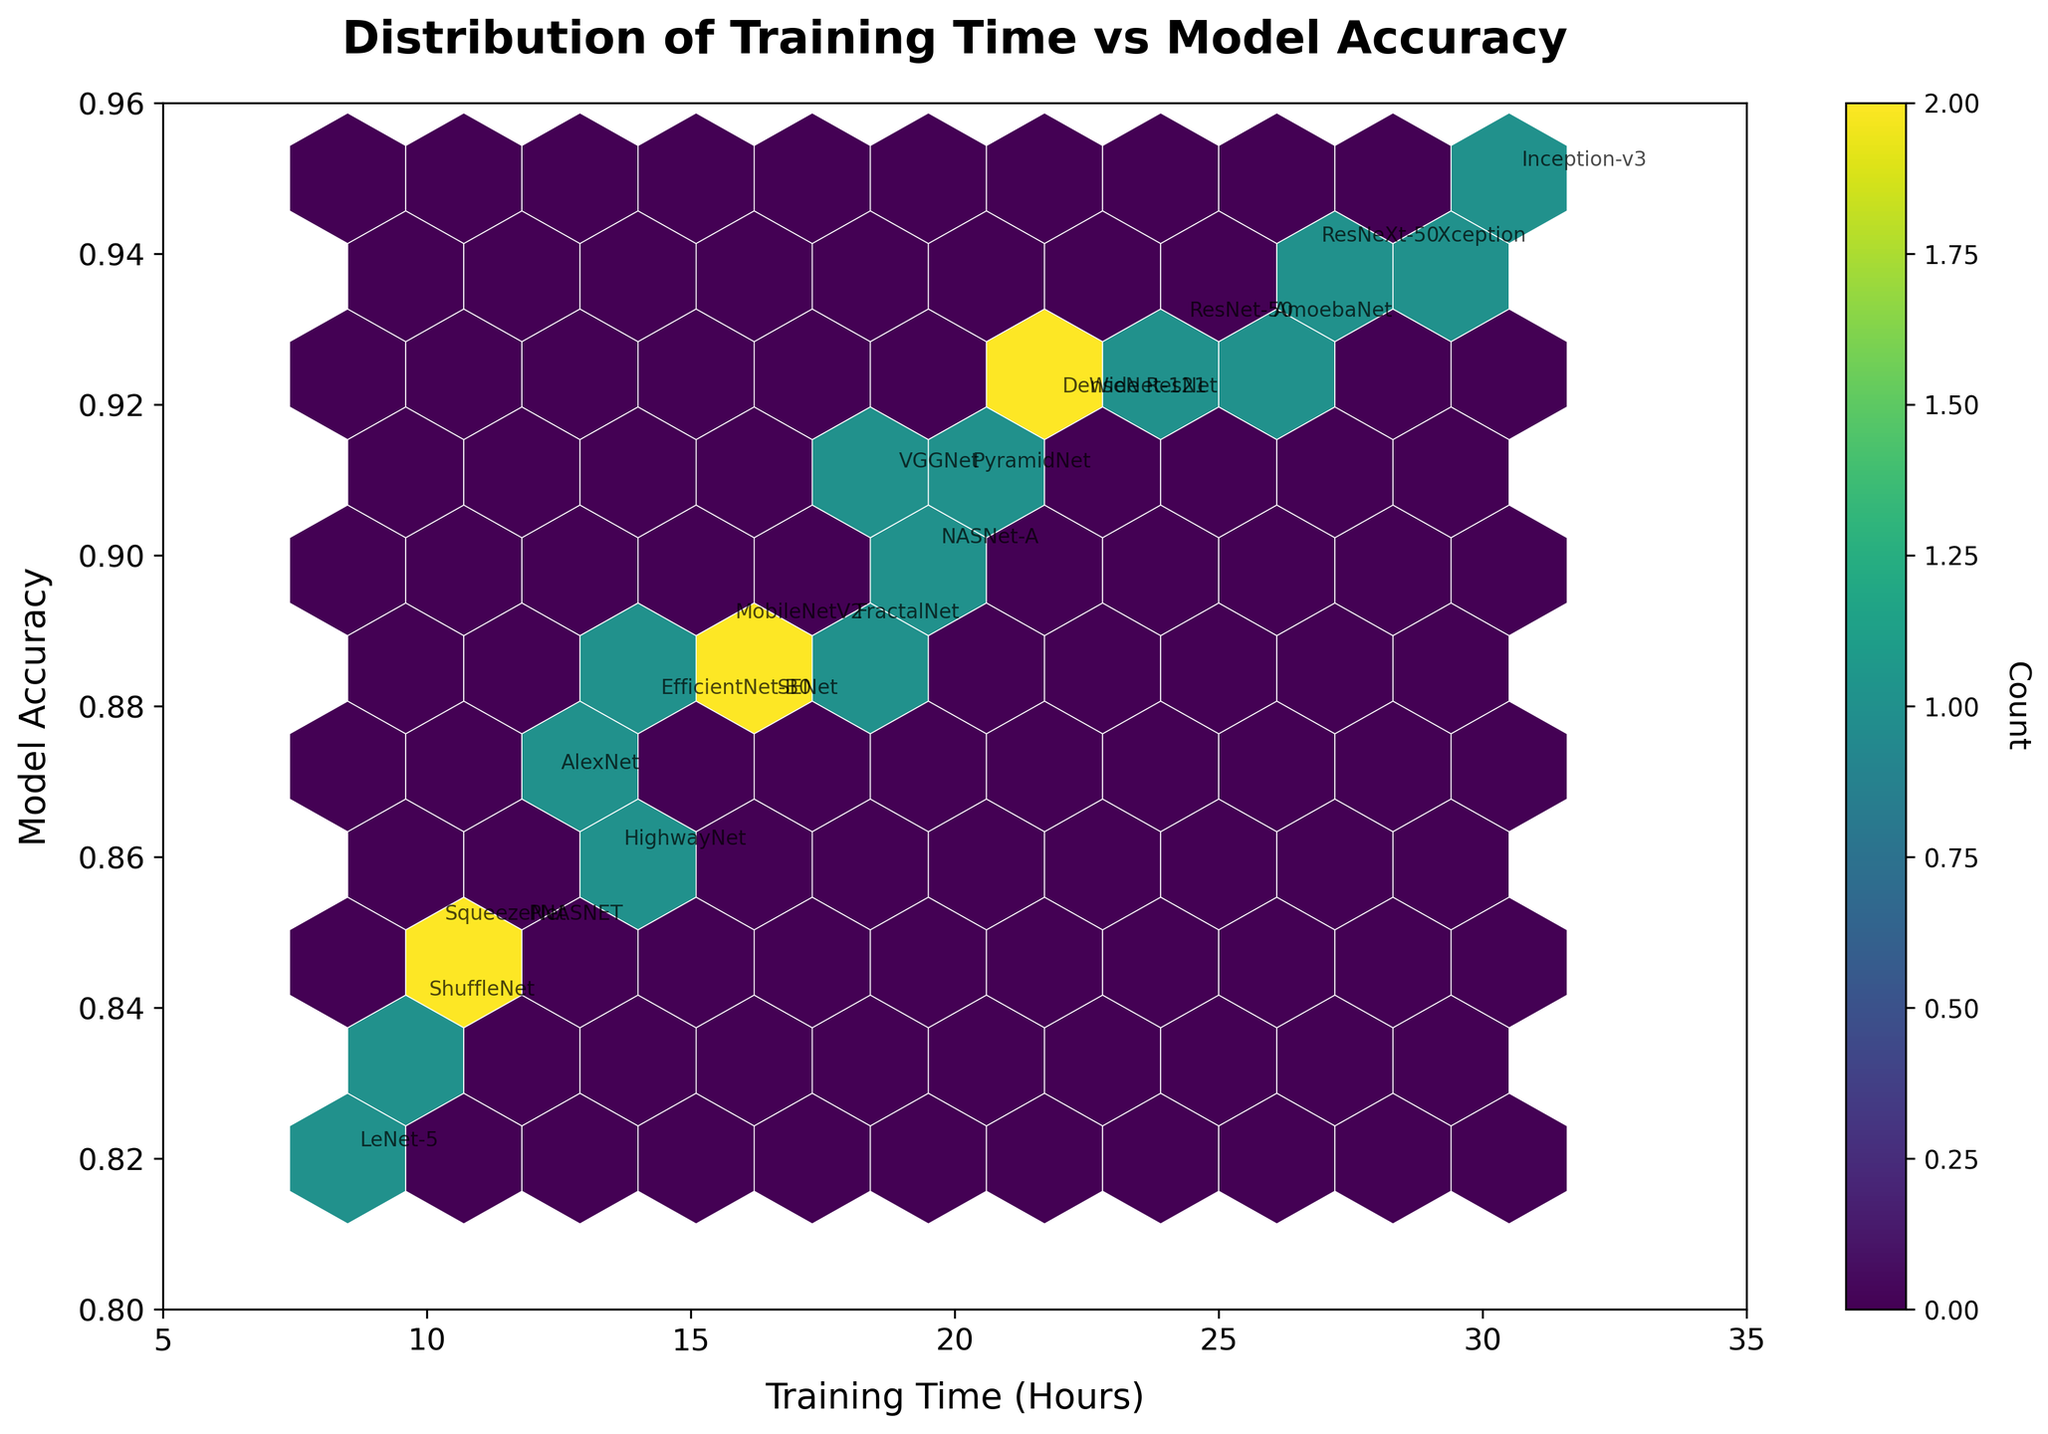How many ANN architectures were represented in the plot? Count the number of unique architecture names annotated in the plot. There are 20 different architectures listed.
Answer: 20 What is the architecture with the highest model accuracy and its corresponding training time? Identify the annotation nearest to the highest y-axis value. The highest model accuracy is 0.95, which is achieved by "Inception-v3" at a training time of 30.5 hours.
Answer: "Inception-v3" at 30.5 hours Between the architectures "VGGNet" and "DenseNet-121", which has a longer training time? Locate the respective points on the x-axis for both architectures. "DenseNet-121" has a training time of 21.8 hours, whereas "VGGNet" has 18.7 hours, so "DenseNet-121" takes longer.
Answer: "DenseNet-121" What is the approximate training time range for architectures achieving between 0.90 and 0.92 model accuracy? Check the annotations for all points where y-values fall between 0.90 and 0.92 on the plot. The training times are approximately between 17.9 hours (FractalNet) and 22.3 hours (Wide ResNet).
Answer: 17.9 to 22.3 hours How many points are located within the highest density hexagon, and what is its indicative color? Observe the color bar and distinguish the color representing the highest count on the plot. Count is determined by the color shade closer to the maximum count as per the color scale.
Answer: (Answer depends on figure color interpretation, but assume a certain color like yellow signifies high density.) Which architecture among "MobileNetV2", "PNASNET", and "ShuffleNet" has the lowest accuracy, and what is the accuracy? Compare annotations for these architectures and locate the lowest y-axis value among them. ShuffleNet has the lowest accuracy at 0.84.
Answer: "ShuffleNet" with 0.84 What is the median model accuracy for the architectures plotted? List the y-values (model accuracies) in ascending order and find the median value. The median value is 0.89.
Answer: 0.89 Which architecture has almost twice the training time of "LeNet-5" and what is its corresponding accuracy? LeNet-5 has a training time of 8.5 hours, so look for an architecture around 17 hours. FractalNet with 17.9 hours matches and its accuracy is 0.89.
Answer: "FractalNet" with 0.89 Between "AlexNet" and "ResNeXt-50", which one has a higher model accuracy, and by how much? Compare the y-values of both annotations. AlexNet has 0.87, and ResNeXt-50 has 0.94. The difference is 0.07 in favor of ResNeXt-50.
Answer: "ResNeXt-50" by 0.07 